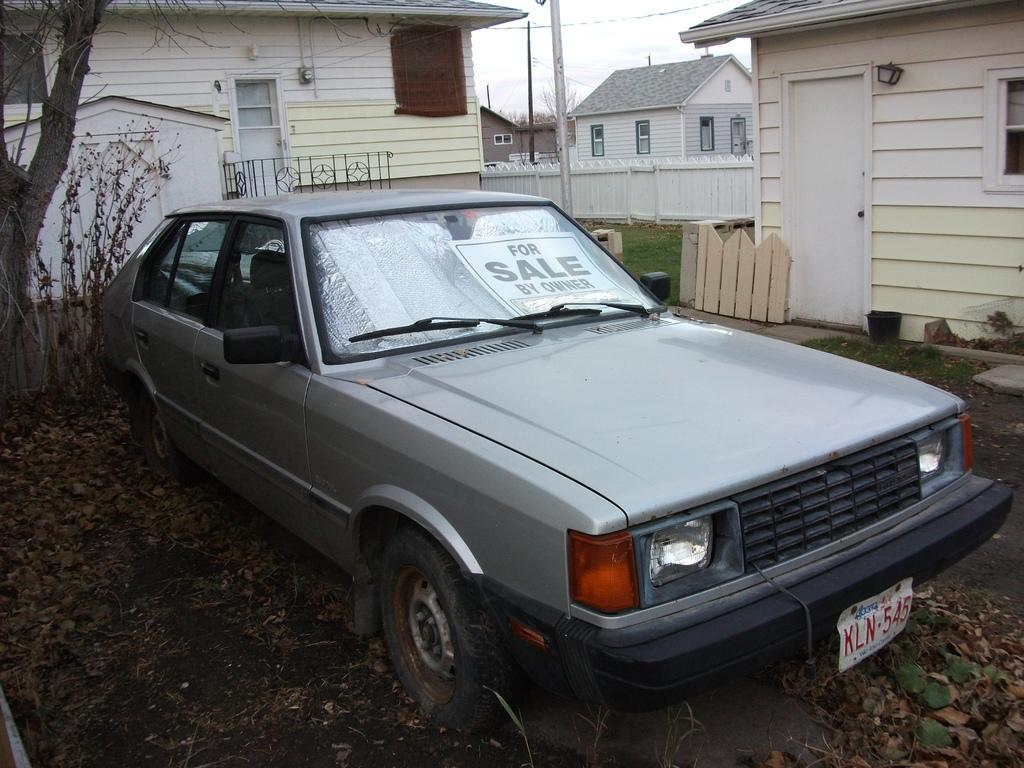What is the main subject of the image? There is a vehicle in the image. What can be seen on the ground in the image? Dried leaves are present on the ground. What is visible in the background of the image? There are houses, trees, poles, and the sky visible in the background of the image. How does the vehicle bring pleasure to the people during the rainstorm in the image? There is no rainstorm present in the image, and therefore no pleasure can be derived from the vehicle in that context. 